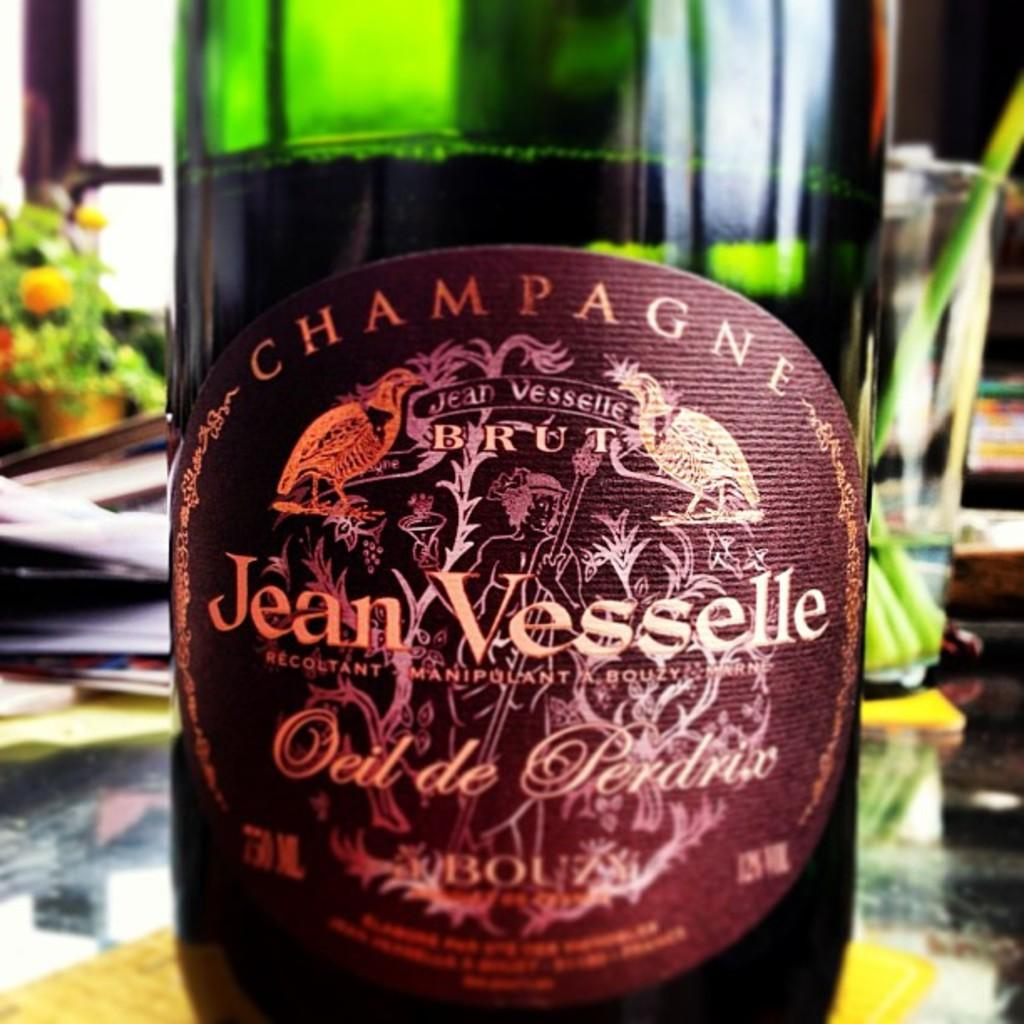<image>
Create a compact narrative representing the image presented. A bottle of Jean Vesselle Champagne sitting on a table. 